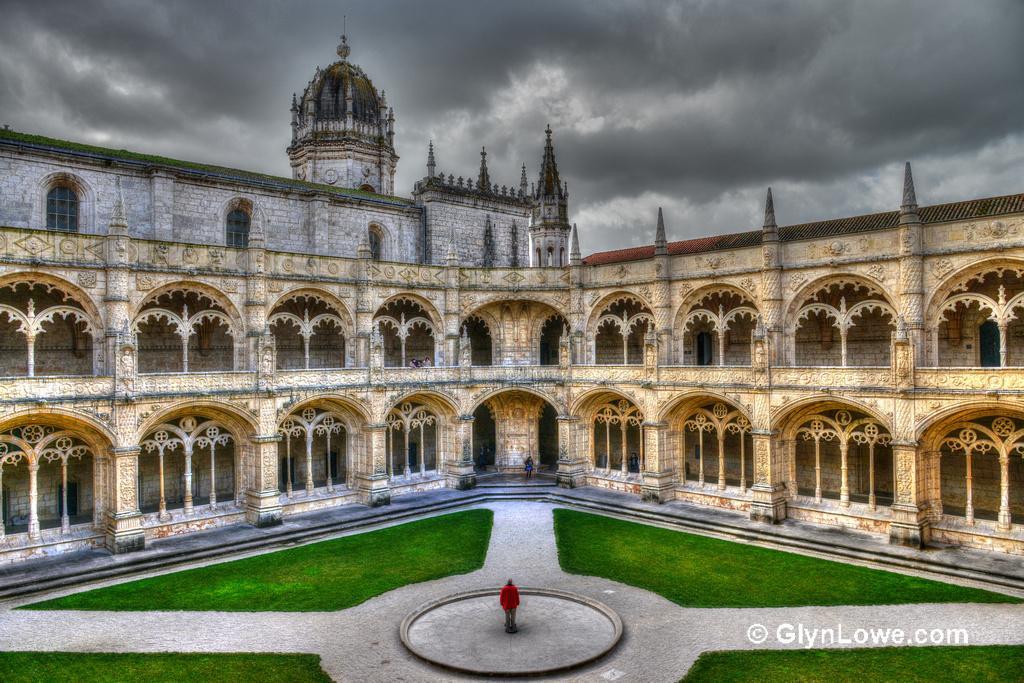Please provide a concise description of this image. In the image there is a building with walls, windows, pillars, arches and also there are steps. At the bottom of the image on the ground there is grass and also there is a statue in the middle of the circle. At the top of the image there is a sky with clouds. On the right side of the image there is a watermark. 